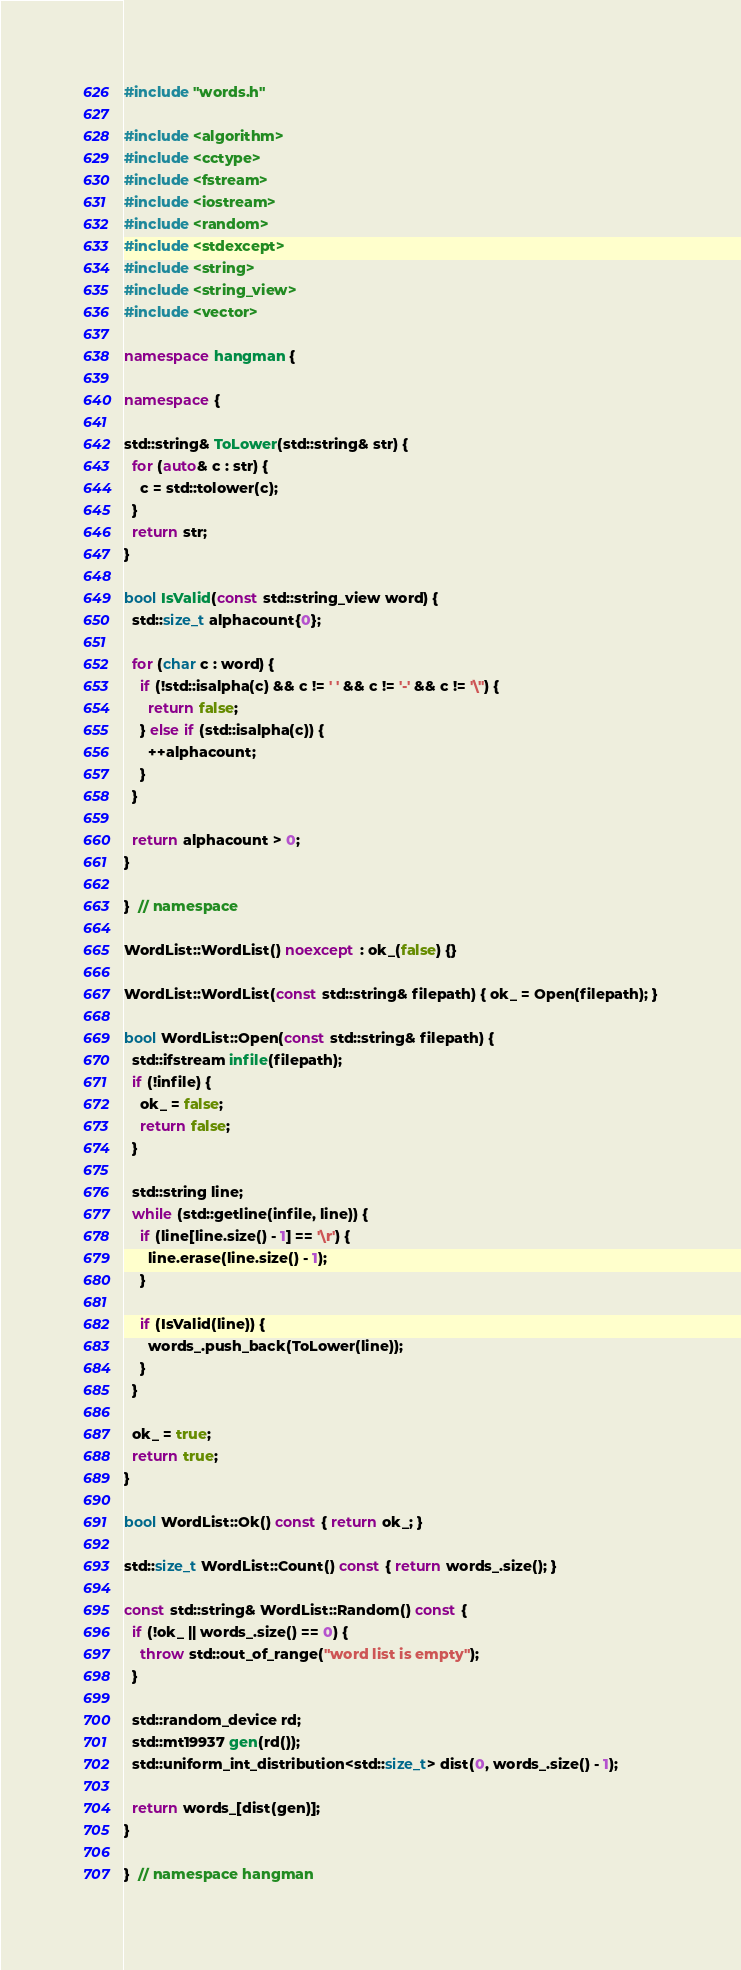<code> <loc_0><loc_0><loc_500><loc_500><_C++_>#include "words.h"

#include <algorithm>
#include <cctype>
#include <fstream>
#include <iostream>
#include <random>
#include <stdexcept>
#include <string>
#include <string_view>
#include <vector>

namespace hangman {

namespace {

std::string& ToLower(std::string& str) {
  for (auto& c : str) {
    c = std::tolower(c);
  }
  return str;
}

bool IsValid(const std::string_view word) {
  std::size_t alphacount{0};

  for (char c : word) {
    if (!std::isalpha(c) && c != ' ' && c != '-' && c != '\'') {
      return false;
    } else if (std::isalpha(c)) {
      ++alphacount;
    }
  }

  return alphacount > 0;
}

}  // namespace

WordList::WordList() noexcept : ok_(false) {}

WordList::WordList(const std::string& filepath) { ok_ = Open(filepath); }

bool WordList::Open(const std::string& filepath) {
  std::ifstream infile(filepath);
  if (!infile) {
    ok_ = false;
    return false;
  }

  std::string line;
  while (std::getline(infile, line)) {
    if (line[line.size() - 1] == '\r') {
      line.erase(line.size() - 1);
    }

    if (IsValid(line)) {
      words_.push_back(ToLower(line));
    }
  }

  ok_ = true;
  return true;
}

bool WordList::Ok() const { return ok_; }

std::size_t WordList::Count() const { return words_.size(); }

const std::string& WordList::Random() const {
  if (!ok_ || words_.size() == 0) {
    throw std::out_of_range("word list is empty");
  }

  std::random_device rd;
  std::mt19937 gen(rd());
  std::uniform_int_distribution<std::size_t> dist(0, words_.size() - 1);

  return words_[dist(gen)];
}

}  // namespace hangman
</code> 